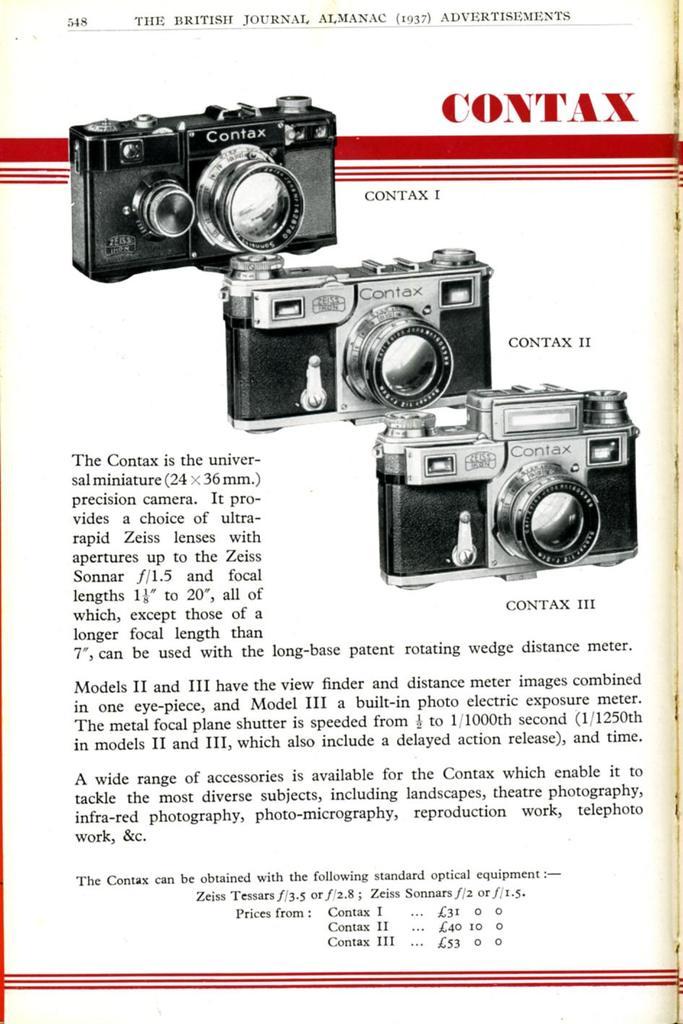What brand are these cameras?
Your response must be concise. Contax. How much does a contax one cost?
Provide a succinct answer. 31. 